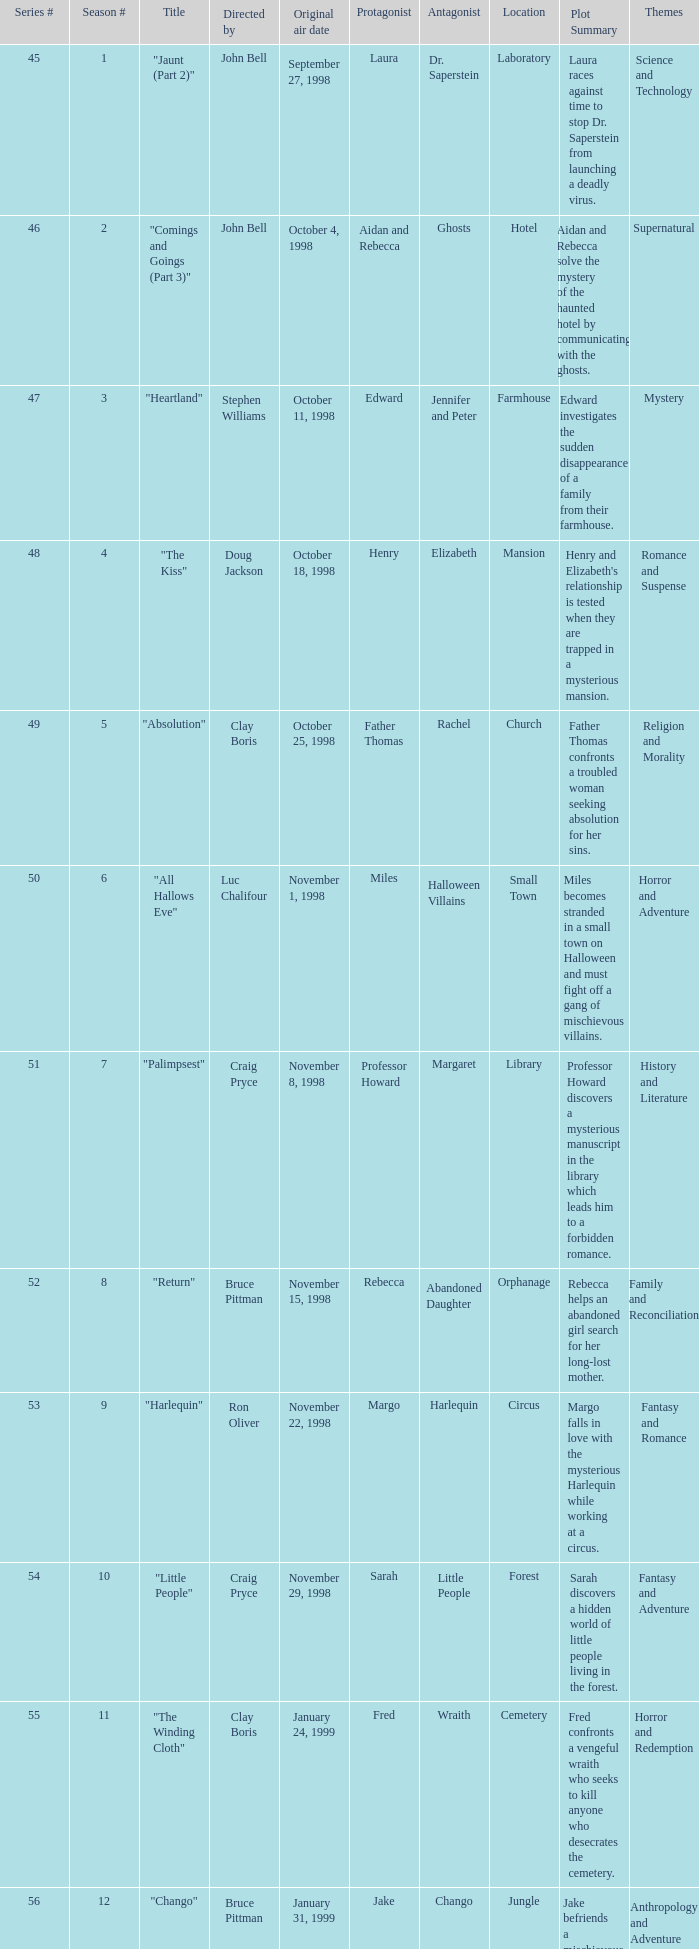Which Season # has a Title of "jaunt (part 2)", and a Series # larger than 45? None. 